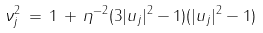<formula> <loc_0><loc_0><loc_500><loc_500>\nu ^ { 2 } _ { j } \, = \, 1 \, + \, \eta ^ { - 2 } ( 3 | u _ { j } | ^ { 2 } - 1 ) ( | u _ { j } | ^ { 2 } - 1 )</formula> 